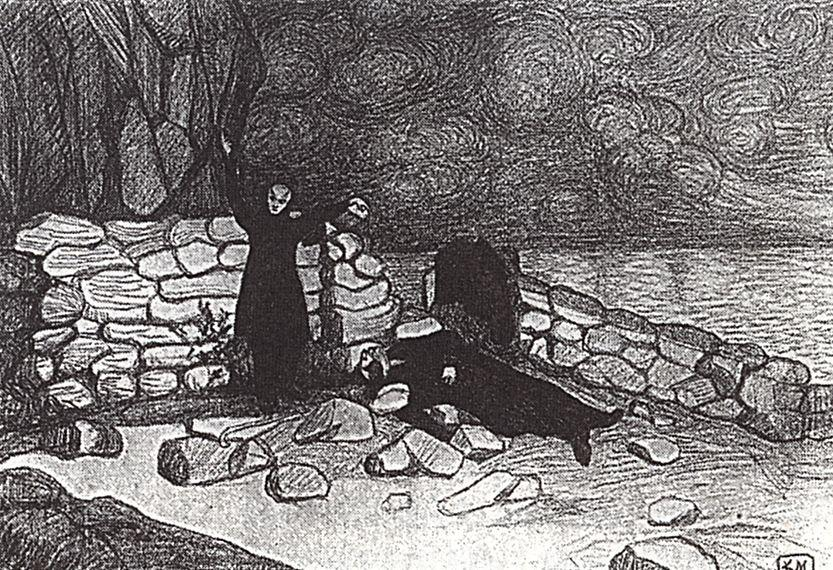Can you explore the artistic style used in this sketch? The artistic style of this sketch is reminiscent of impressionism which is characterized by an emphasis on light and its changing qualities, often with a focus on the overall effect rather than precise detail. In this sketch, the broad, expressive brush strokes create a dynamic texture, particularly in the depiction of the swirling clouds and rugged terrain, which captures the essence and emotion of the scene rather than its exact physical details. 